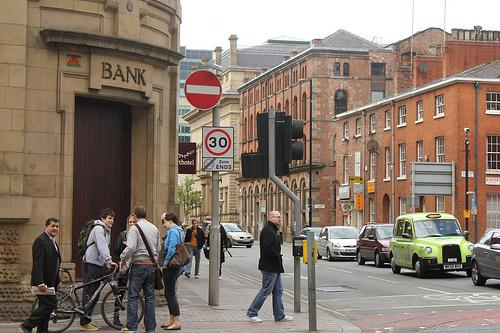Question: how many vehicles are in the street?
Choices:
A. 4.
B. 6.
C. 8.
D. 2.
Answer with the letter. Answer: B Question: what color is the sign with the white line?
Choices:
A. Green.
B. Yellow.
C. Black.
D. Red.
Answer with the letter. Answer: D Question: where was the image taken?
Choices:
A. Near a bank.
B. In the driveway.
C. In the kitchen.
D. In the lobby.
Answer with the letter. Answer: A Question: how many people are on the sidewalk?
Choices:
A. 9.
B. 4.
C. 6.
D. 8.
Answer with the letter. Answer: D 